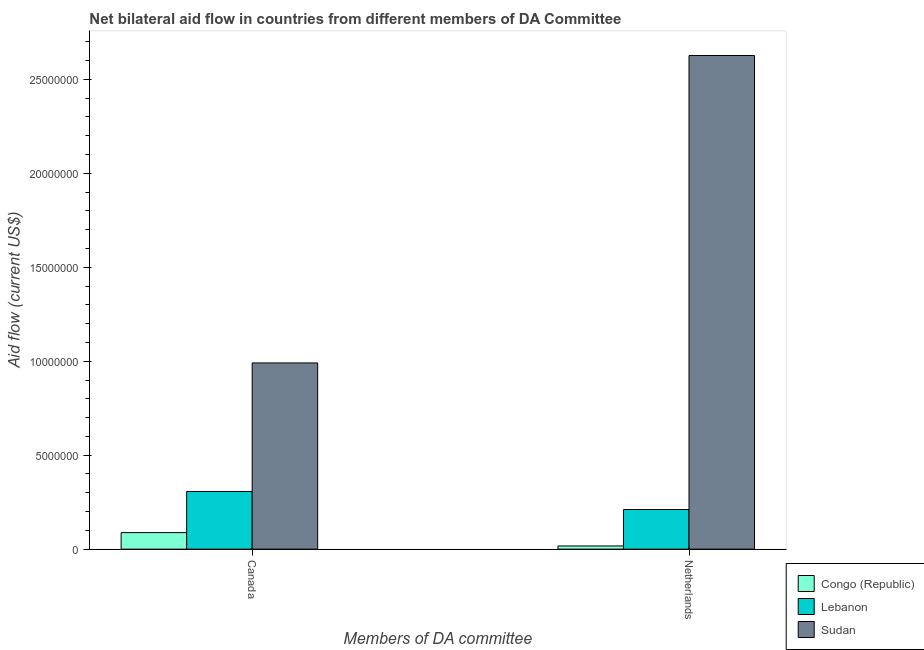How many different coloured bars are there?
Your answer should be compact. 3. Are the number of bars per tick equal to the number of legend labels?
Offer a very short reply. Yes. How many bars are there on the 2nd tick from the right?
Provide a short and direct response. 3. What is the amount of aid given by netherlands in Congo (Republic)?
Offer a terse response. 1.70e+05. Across all countries, what is the maximum amount of aid given by canada?
Offer a terse response. 9.91e+06. Across all countries, what is the minimum amount of aid given by canada?
Provide a succinct answer. 8.80e+05. In which country was the amount of aid given by canada maximum?
Give a very brief answer. Sudan. In which country was the amount of aid given by canada minimum?
Offer a terse response. Congo (Republic). What is the total amount of aid given by netherlands in the graph?
Your response must be concise. 2.86e+07. What is the difference between the amount of aid given by canada in Sudan and that in Congo (Republic)?
Your response must be concise. 9.03e+06. What is the difference between the amount of aid given by netherlands in Sudan and the amount of aid given by canada in Congo (Republic)?
Your response must be concise. 2.54e+07. What is the average amount of aid given by netherlands per country?
Keep it short and to the point. 9.52e+06. What is the difference between the amount of aid given by netherlands and amount of aid given by canada in Sudan?
Offer a very short reply. 1.64e+07. What is the ratio of the amount of aid given by canada in Lebanon to that in Sudan?
Your answer should be compact. 0.31. What does the 2nd bar from the left in Canada represents?
Provide a short and direct response. Lebanon. What does the 3rd bar from the right in Netherlands represents?
Your answer should be compact. Congo (Republic). How many bars are there?
Make the answer very short. 6. Are the values on the major ticks of Y-axis written in scientific E-notation?
Ensure brevity in your answer.  No. How many legend labels are there?
Ensure brevity in your answer.  3. How are the legend labels stacked?
Your answer should be very brief. Vertical. What is the title of the graph?
Offer a terse response. Net bilateral aid flow in countries from different members of DA Committee. What is the label or title of the X-axis?
Give a very brief answer. Members of DA committee. What is the label or title of the Y-axis?
Offer a very short reply. Aid flow (current US$). What is the Aid flow (current US$) in Congo (Republic) in Canada?
Make the answer very short. 8.80e+05. What is the Aid flow (current US$) in Lebanon in Canada?
Offer a very short reply. 3.07e+06. What is the Aid flow (current US$) in Sudan in Canada?
Provide a short and direct response. 9.91e+06. What is the Aid flow (current US$) in Congo (Republic) in Netherlands?
Your response must be concise. 1.70e+05. What is the Aid flow (current US$) in Lebanon in Netherlands?
Your answer should be very brief. 2.11e+06. What is the Aid flow (current US$) of Sudan in Netherlands?
Your answer should be compact. 2.63e+07. Across all Members of DA committee, what is the maximum Aid flow (current US$) of Congo (Republic)?
Make the answer very short. 8.80e+05. Across all Members of DA committee, what is the maximum Aid flow (current US$) in Lebanon?
Keep it short and to the point. 3.07e+06. Across all Members of DA committee, what is the maximum Aid flow (current US$) of Sudan?
Ensure brevity in your answer.  2.63e+07. Across all Members of DA committee, what is the minimum Aid flow (current US$) of Congo (Republic)?
Offer a terse response. 1.70e+05. Across all Members of DA committee, what is the minimum Aid flow (current US$) of Lebanon?
Give a very brief answer. 2.11e+06. Across all Members of DA committee, what is the minimum Aid flow (current US$) of Sudan?
Keep it short and to the point. 9.91e+06. What is the total Aid flow (current US$) in Congo (Republic) in the graph?
Offer a very short reply. 1.05e+06. What is the total Aid flow (current US$) of Lebanon in the graph?
Provide a succinct answer. 5.18e+06. What is the total Aid flow (current US$) of Sudan in the graph?
Provide a succinct answer. 3.62e+07. What is the difference between the Aid flow (current US$) of Congo (Republic) in Canada and that in Netherlands?
Your answer should be very brief. 7.10e+05. What is the difference between the Aid flow (current US$) of Lebanon in Canada and that in Netherlands?
Provide a succinct answer. 9.60e+05. What is the difference between the Aid flow (current US$) in Sudan in Canada and that in Netherlands?
Provide a short and direct response. -1.64e+07. What is the difference between the Aid flow (current US$) in Congo (Republic) in Canada and the Aid flow (current US$) in Lebanon in Netherlands?
Offer a terse response. -1.23e+06. What is the difference between the Aid flow (current US$) in Congo (Republic) in Canada and the Aid flow (current US$) in Sudan in Netherlands?
Your response must be concise. -2.54e+07. What is the difference between the Aid flow (current US$) of Lebanon in Canada and the Aid flow (current US$) of Sudan in Netherlands?
Offer a very short reply. -2.32e+07. What is the average Aid flow (current US$) in Congo (Republic) per Members of DA committee?
Provide a short and direct response. 5.25e+05. What is the average Aid flow (current US$) of Lebanon per Members of DA committee?
Your answer should be compact. 2.59e+06. What is the average Aid flow (current US$) in Sudan per Members of DA committee?
Your answer should be very brief. 1.81e+07. What is the difference between the Aid flow (current US$) in Congo (Republic) and Aid flow (current US$) in Lebanon in Canada?
Your response must be concise. -2.19e+06. What is the difference between the Aid flow (current US$) in Congo (Republic) and Aid flow (current US$) in Sudan in Canada?
Offer a terse response. -9.03e+06. What is the difference between the Aid flow (current US$) of Lebanon and Aid flow (current US$) of Sudan in Canada?
Give a very brief answer. -6.84e+06. What is the difference between the Aid flow (current US$) of Congo (Republic) and Aid flow (current US$) of Lebanon in Netherlands?
Your answer should be very brief. -1.94e+06. What is the difference between the Aid flow (current US$) of Congo (Republic) and Aid flow (current US$) of Sudan in Netherlands?
Ensure brevity in your answer.  -2.61e+07. What is the difference between the Aid flow (current US$) in Lebanon and Aid flow (current US$) in Sudan in Netherlands?
Ensure brevity in your answer.  -2.42e+07. What is the ratio of the Aid flow (current US$) in Congo (Republic) in Canada to that in Netherlands?
Provide a short and direct response. 5.18. What is the ratio of the Aid flow (current US$) of Lebanon in Canada to that in Netherlands?
Offer a terse response. 1.46. What is the ratio of the Aid flow (current US$) of Sudan in Canada to that in Netherlands?
Offer a very short reply. 0.38. What is the difference between the highest and the second highest Aid flow (current US$) of Congo (Republic)?
Provide a succinct answer. 7.10e+05. What is the difference between the highest and the second highest Aid flow (current US$) of Lebanon?
Your answer should be very brief. 9.60e+05. What is the difference between the highest and the second highest Aid flow (current US$) of Sudan?
Make the answer very short. 1.64e+07. What is the difference between the highest and the lowest Aid flow (current US$) in Congo (Republic)?
Your response must be concise. 7.10e+05. What is the difference between the highest and the lowest Aid flow (current US$) of Lebanon?
Offer a terse response. 9.60e+05. What is the difference between the highest and the lowest Aid flow (current US$) in Sudan?
Your response must be concise. 1.64e+07. 